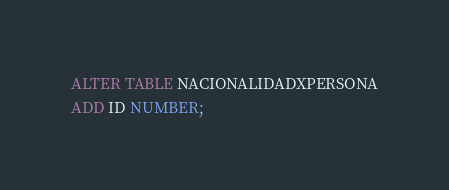Convert code to text. <code><loc_0><loc_0><loc_500><loc_500><_SQL_>ALTER TABLE NACIONALIDADXPERSONA
ADD ID NUMBER;</code> 